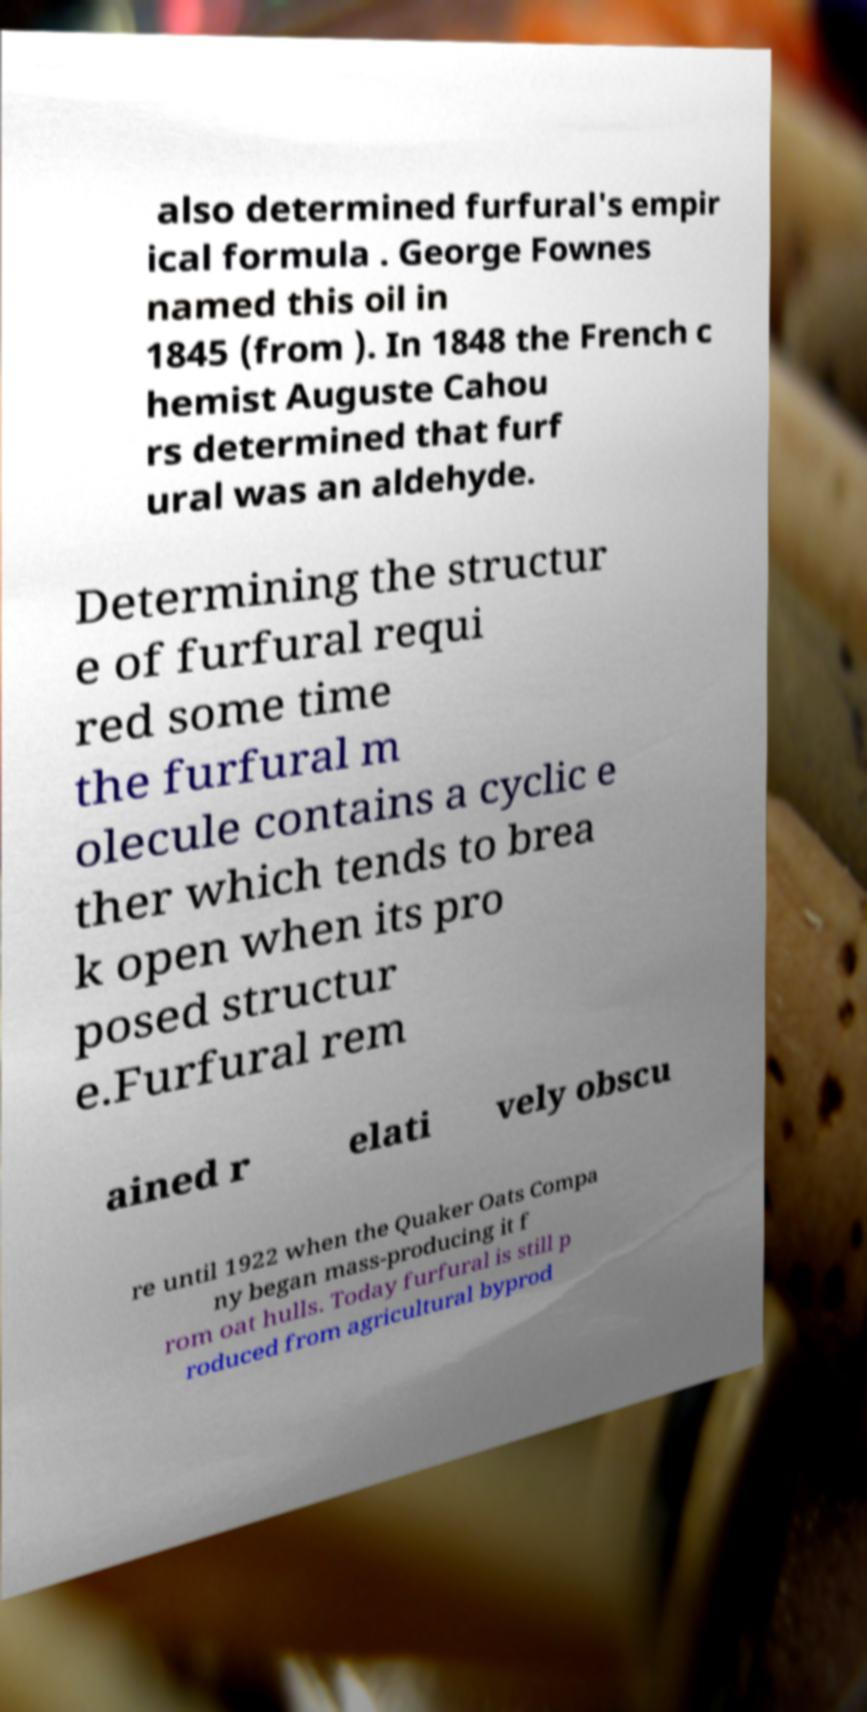What messages or text are displayed in this image? I need them in a readable, typed format. also determined furfural's empir ical formula . George Fownes named this oil in 1845 (from ). In 1848 the French c hemist Auguste Cahou rs determined that furf ural was an aldehyde. Determining the structur e of furfural requi red some time the furfural m olecule contains a cyclic e ther which tends to brea k open when its pro posed structur e.Furfural rem ained r elati vely obscu re until 1922 when the Quaker Oats Compa ny began mass-producing it f rom oat hulls. Today furfural is still p roduced from agricultural byprod 